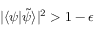<formula> <loc_0><loc_0><loc_500><loc_500>| \langle \psi | \tilde { \psi } \rangle | ^ { 2 } > 1 - \epsilon</formula> 